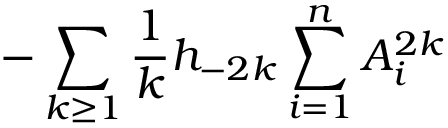Convert formula to latex. <formula><loc_0><loc_0><loc_500><loc_500>- \sum _ { k \geq 1 } { \frac { 1 } { k } } h _ { - 2 k } \sum _ { i = 1 } ^ { n } A _ { i } ^ { 2 k }</formula> 